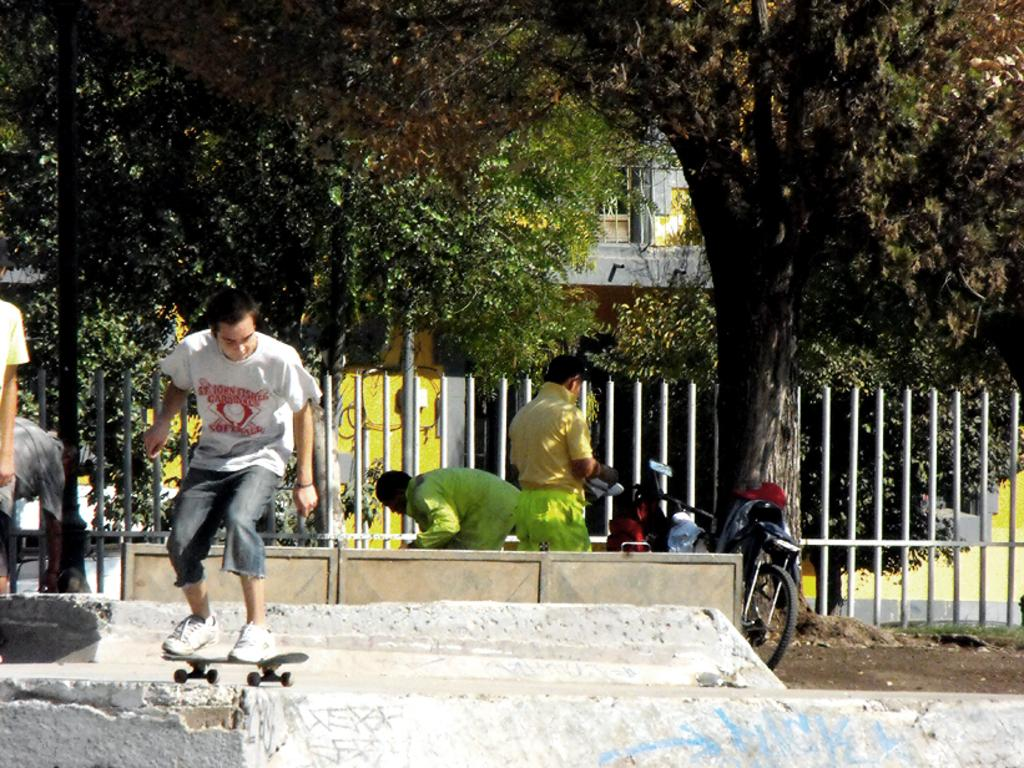What is the person in the image doing? The person in the image is on a skateboard. What can be seen in the background of the image? There is fencing, trees, and a building visible in the background. What other mode of transportation is present in the image? There is a bicycle in the image. What type of cheese is the person on the skateboard holding in the image? There is no cheese present in the image; the person is on a skateboard and there are no food items mentioned. 